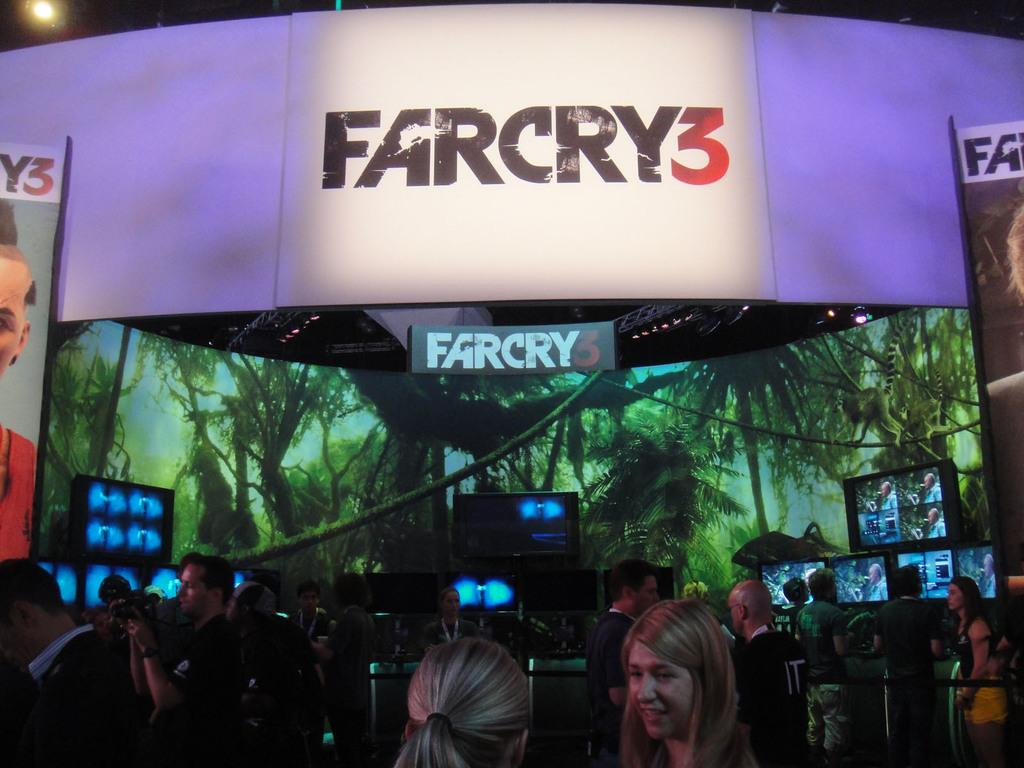How many people are in the image? There is a group of people in the image. What are the people doing in the image? The people are standing. What objects can be seen in the image besides the people? There are screens and boards in the image. Can you see a squirrel carrying a yoke in the image? No, there is no squirrel carrying a yoke in the image. 